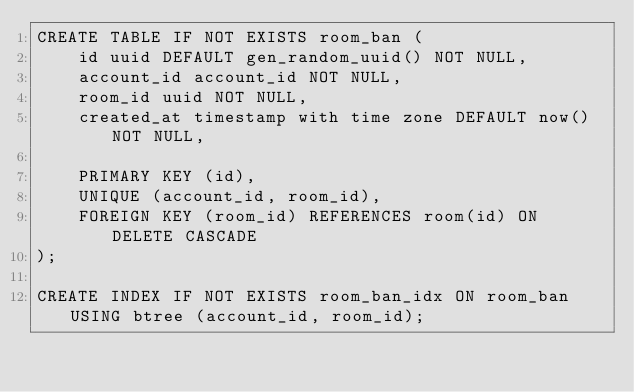<code> <loc_0><loc_0><loc_500><loc_500><_SQL_>CREATE TABLE IF NOT EXISTS room_ban (
    id uuid DEFAULT gen_random_uuid() NOT NULL,
    account_id account_id NOT NULL,
    room_id uuid NOT NULL,
    created_at timestamp with time zone DEFAULT now() NOT NULL,

    PRIMARY KEY (id),
    UNIQUE (account_id, room_id),
    FOREIGN KEY (room_id) REFERENCES room(id) ON DELETE CASCADE
);

CREATE INDEX IF NOT EXISTS room_ban_idx ON room_ban USING btree (account_id, room_id);
</code> 